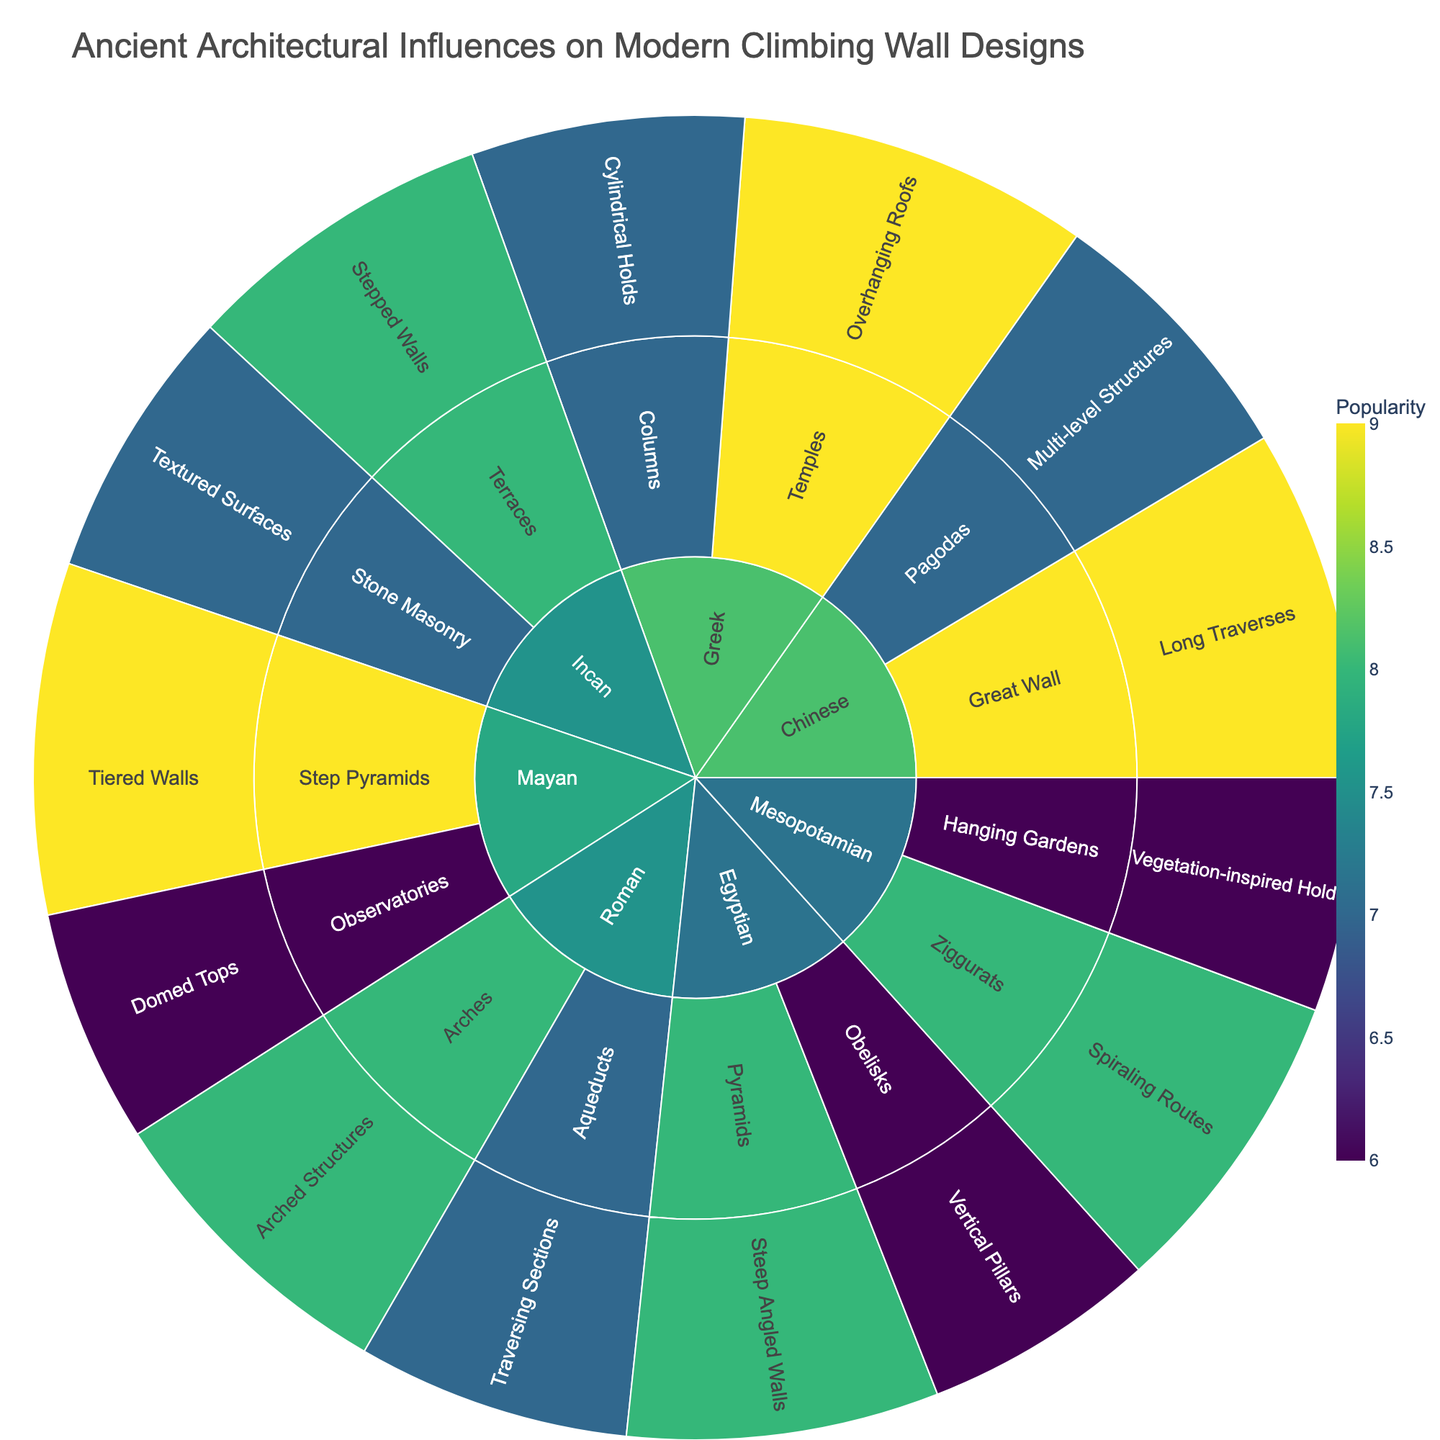What is the title of the sunburst plot? The title is usually displayed at the top of the plot, and it summarizes the content and focus of the figure.
Answer: Ancient Architectural Influences on Modern Climbing Wall Designs Which architectural style under the Egyptian civilization has the higher popularity? Look into the Egyptian civilization section and compare the popularity values of the pyramids and obelisks.
Answer: Pyramids How many modern climbing wall features are inspired by the Greek architectural style? Look at the Greek civilization section and count the number of features listed.
Answer: 2 Which ancient civilization has the most distinct architectural styles presented in the sunburst plot? Identify each civilization and count the architectural styles associated with them.
Answer: Each civilization has 2 distinct architectural styles Which civilization's architectural style contributes the most to modern climbing wall designs according to popularity? Sum the popularity values for each civilization and find the one with the highest total.
Answer: Chinese (Total Popularity: 16) What is the average popularity of the modern climbing wall features inspired by the Roman architectural styles? Calculate the average by adding the popularity values for arches and aqueducts, then divide by 2.
Answer: 7.5 Which modern climbing wall feature inspired by the Mayan civilization is the most popular? Identify the Mayan section and compare the popularity values for step pyramids and observatories.
Answer: Tiered Walls Which civilization has the least popular modern climbing wall feature, and what is that feature? Compare the lowest popularity values across all civilizations and identify the corresponding feature.
Answer: Mesopotamian; Vegetation-inspired Holds Are overhanging roofs or arched structures more popular in modern climbing wall designs? Compare the popularity values for these two specific features.
Answer: Overhanging Roofs What is the total popularity of modern climbing wall features inspired by ancient civilizations with masonry as a key architectural style? Identify textual surface and step walls related to Incan stone masonry and sum their popularity values.
Answer: 15 